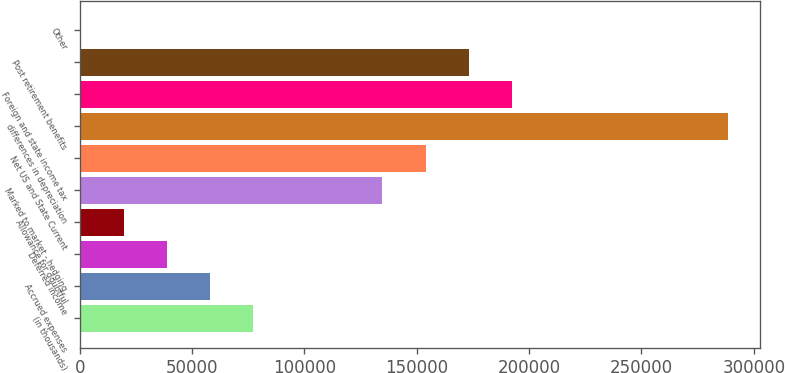<chart> <loc_0><loc_0><loc_500><loc_500><bar_chart><fcel>(in thousands)<fcel>Accrued expenses<fcel>Deferred income<fcel>Allowance for doubtful<fcel>Marked to market - hedging<fcel>Net US and State Current<fcel>differences in depreciation<fcel>Foreign and state income tax<fcel>Post retirement benefits<fcel>Other<nl><fcel>77089<fcel>57878<fcel>38667<fcel>19456<fcel>134722<fcel>153933<fcel>288410<fcel>192355<fcel>173144<fcel>245<nl></chart> 